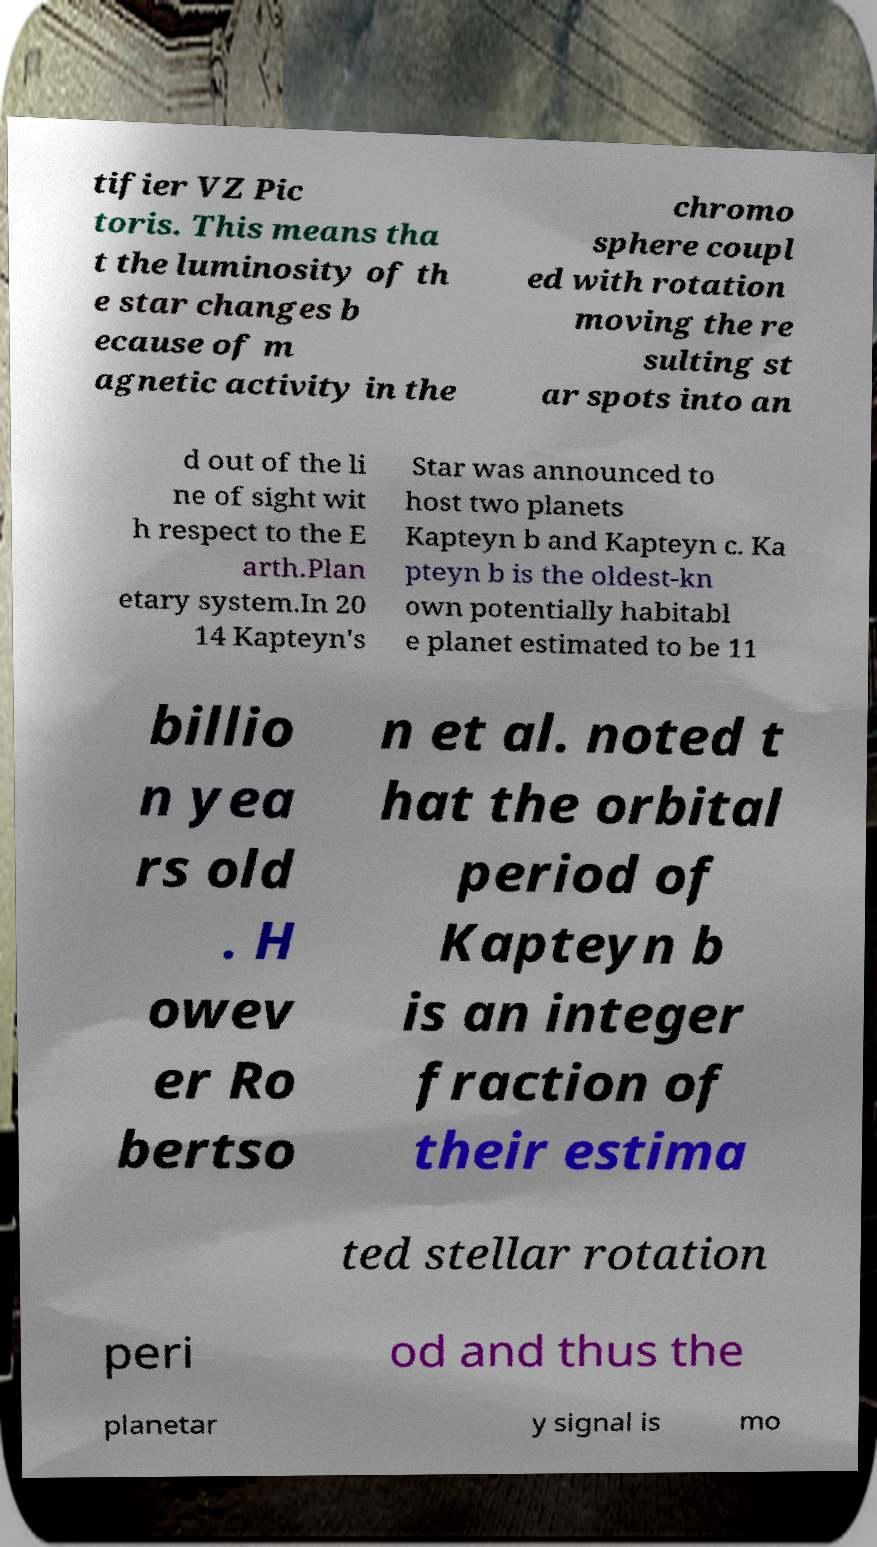Can you accurately transcribe the text from the provided image for me? tifier VZ Pic toris. This means tha t the luminosity of th e star changes b ecause of m agnetic activity in the chromo sphere coupl ed with rotation moving the re sulting st ar spots into an d out of the li ne of sight wit h respect to the E arth.Plan etary system.In 20 14 Kapteyn's Star was announced to host two planets Kapteyn b and Kapteyn c. Ka pteyn b is the oldest-kn own potentially habitabl e planet estimated to be 11 billio n yea rs old . H owev er Ro bertso n et al. noted t hat the orbital period of Kapteyn b is an integer fraction of their estima ted stellar rotation peri od and thus the planetar y signal is mo 